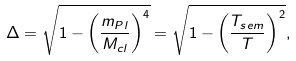Convert formula to latex. <formula><loc_0><loc_0><loc_500><loc_500>\Delta = \sqrt { 1 - \left ( \frac { m _ { P l } } { M _ { c l } } \right ) ^ { 4 } } = \sqrt { 1 - \left ( \frac { T _ { s e m } } { T } \right ) ^ { 2 } } ,</formula> 